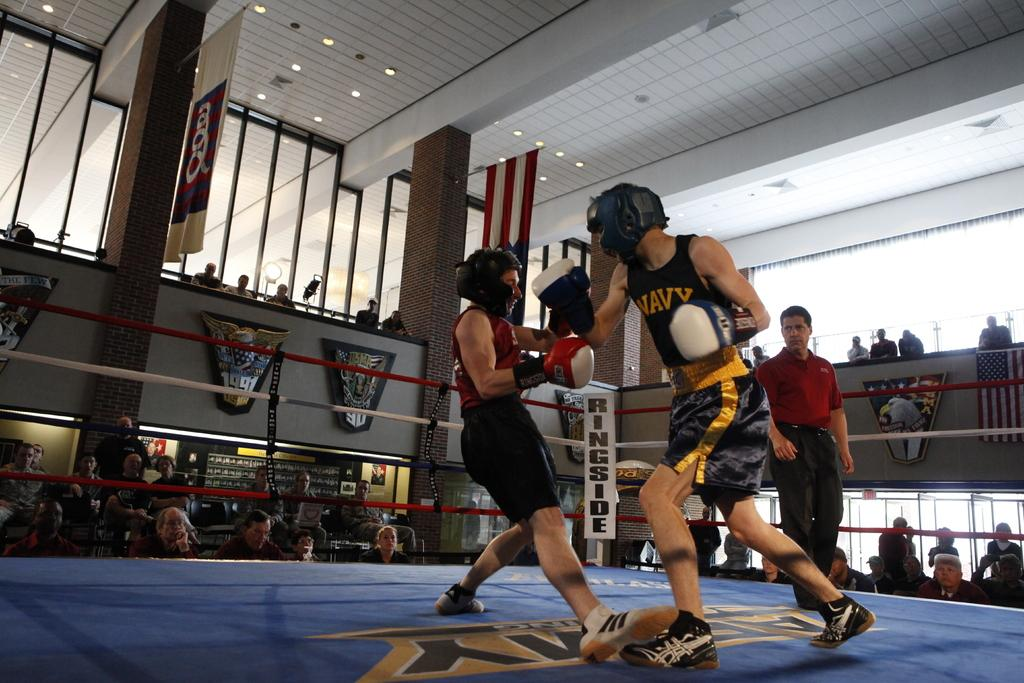<image>
Offer a succinct explanation of the picture presented. The fighter wearing the black and gold uniform is on the Navy team. 